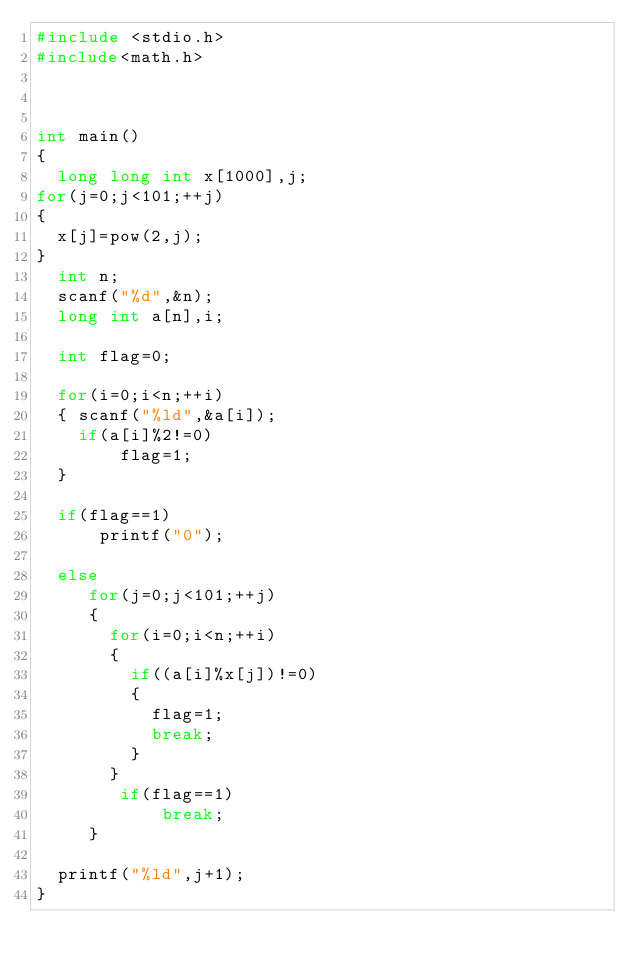<code> <loc_0><loc_0><loc_500><loc_500><_C_>#include <stdio.h>
#include<math.h>
 
 
 
int main()
{
  long long int x[1000],j;
for(j=0;j<101;++j)
{
  x[j]=pow(2,j);
}
  int n;
  scanf("%d",&n);
  long int a[n],i;
 
  int flag=0;
  
  for(i=0;i<n;++i)
  { scanf("%ld",&a[i]);
    if(a[i]%2!=0)
        flag=1;
  }
  
  if(flag==1)
      printf("0");
  
  else
     for(j=0;j<101;++j)
     {
       for(i=0;i<n;++i) 
       {
         if((a[i]%x[j])!=0)
         {
           flag=1;
           break;
         }
       }
        if(flag==1)
            break;
     }
  
  printf("%ld",j+1);
}
    </code> 